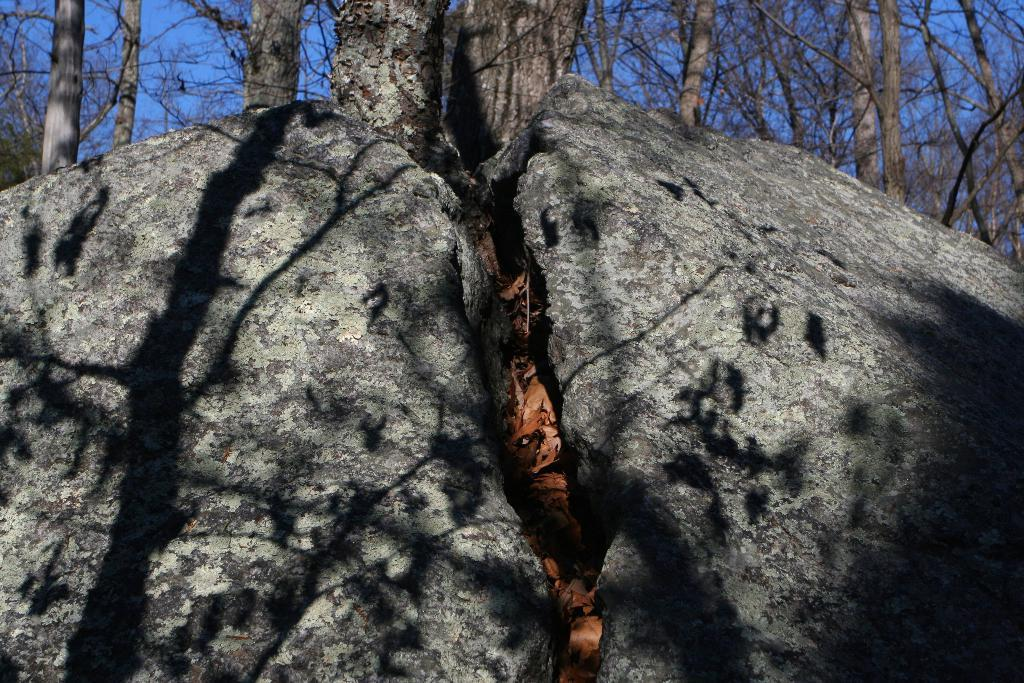What is the main subject in the image? There is a rock in the image. What other natural elements can be seen in the image? There are dried trees in the image. What is the color of the sky in the image? The sky is visible in the image and is blue in color. How many deer can be seen interacting with the rock in the image? There are no deer present in the image; it features a rock and dried trees. What type of society is depicted interacting with the rock in the image? There is no society depicted in the image; it features a rock, dried trees, and a blue sky. 